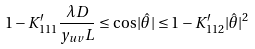Convert formula to latex. <formula><loc_0><loc_0><loc_500><loc_500>1 - K _ { 1 1 1 } ^ { \prime } \frac { \lambda D } { y _ { u v } L } \leq \cos | \hat { \theta } | \leq 1 - K _ { 1 1 2 } ^ { \prime } | \hat { \theta } | ^ { 2 }</formula> 